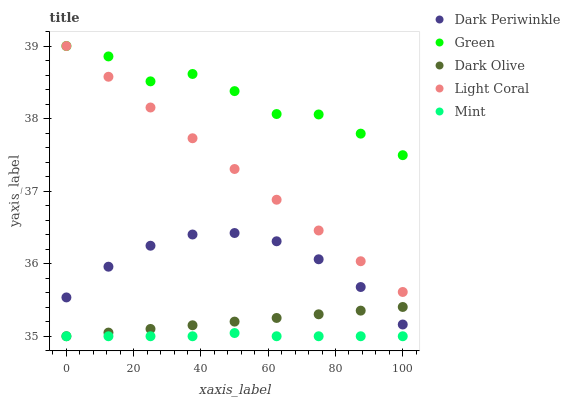Does Mint have the minimum area under the curve?
Answer yes or no. Yes. Does Green have the maximum area under the curve?
Answer yes or no. Yes. Does Dark Olive have the minimum area under the curve?
Answer yes or no. No. Does Dark Olive have the maximum area under the curve?
Answer yes or no. No. Is Dark Olive the smoothest?
Answer yes or no. Yes. Is Green the roughest?
Answer yes or no. Yes. Is Mint the smoothest?
Answer yes or no. No. Is Mint the roughest?
Answer yes or no. No. Does Mint have the lowest value?
Answer yes or no. Yes. Does Green have the lowest value?
Answer yes or no. No. Does Green have the highest value?
Answer yes or no. Yes. Does Dark Olive have the highest value?
Answer yes or no. No. Is Mint less than Light Coral?
Answer yes or no. Yes. Is Dark Periwinkle greater than Mint?
Answer yes or no. Yes. Does Dark Olive intersect Mint?
Answer yes or no. Yes. Is Dark Olive less than Mint?
Answer yes or no. No. Is Dark Olive greater than Mint?
Answer yes or no. No. Does Mint intersect Light Coral?
Answer yes or no. No. 